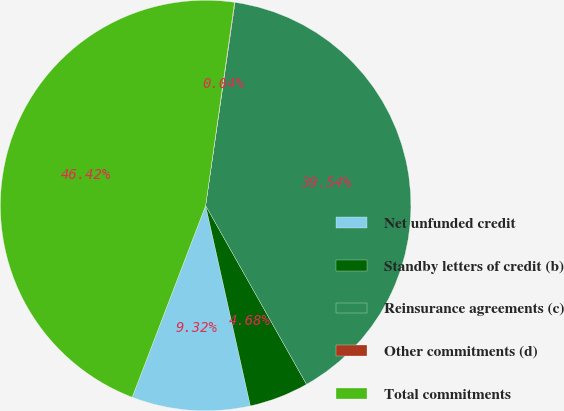Convert chart. <chart><loc_0><loc_0><loc_500><loc_500><pie_chart><fcel>Net unfunded credit<fcel>Standby letters of credit (b)<fcel>Reinsurance agreements (c)<fcel>Other commitments (d)<fcel>Total commitments<nl><fcel>9.32%<fcel>4.68%<fcel>39.54%<fcel>0.04%<fcel>46.42%<nl></chart> 